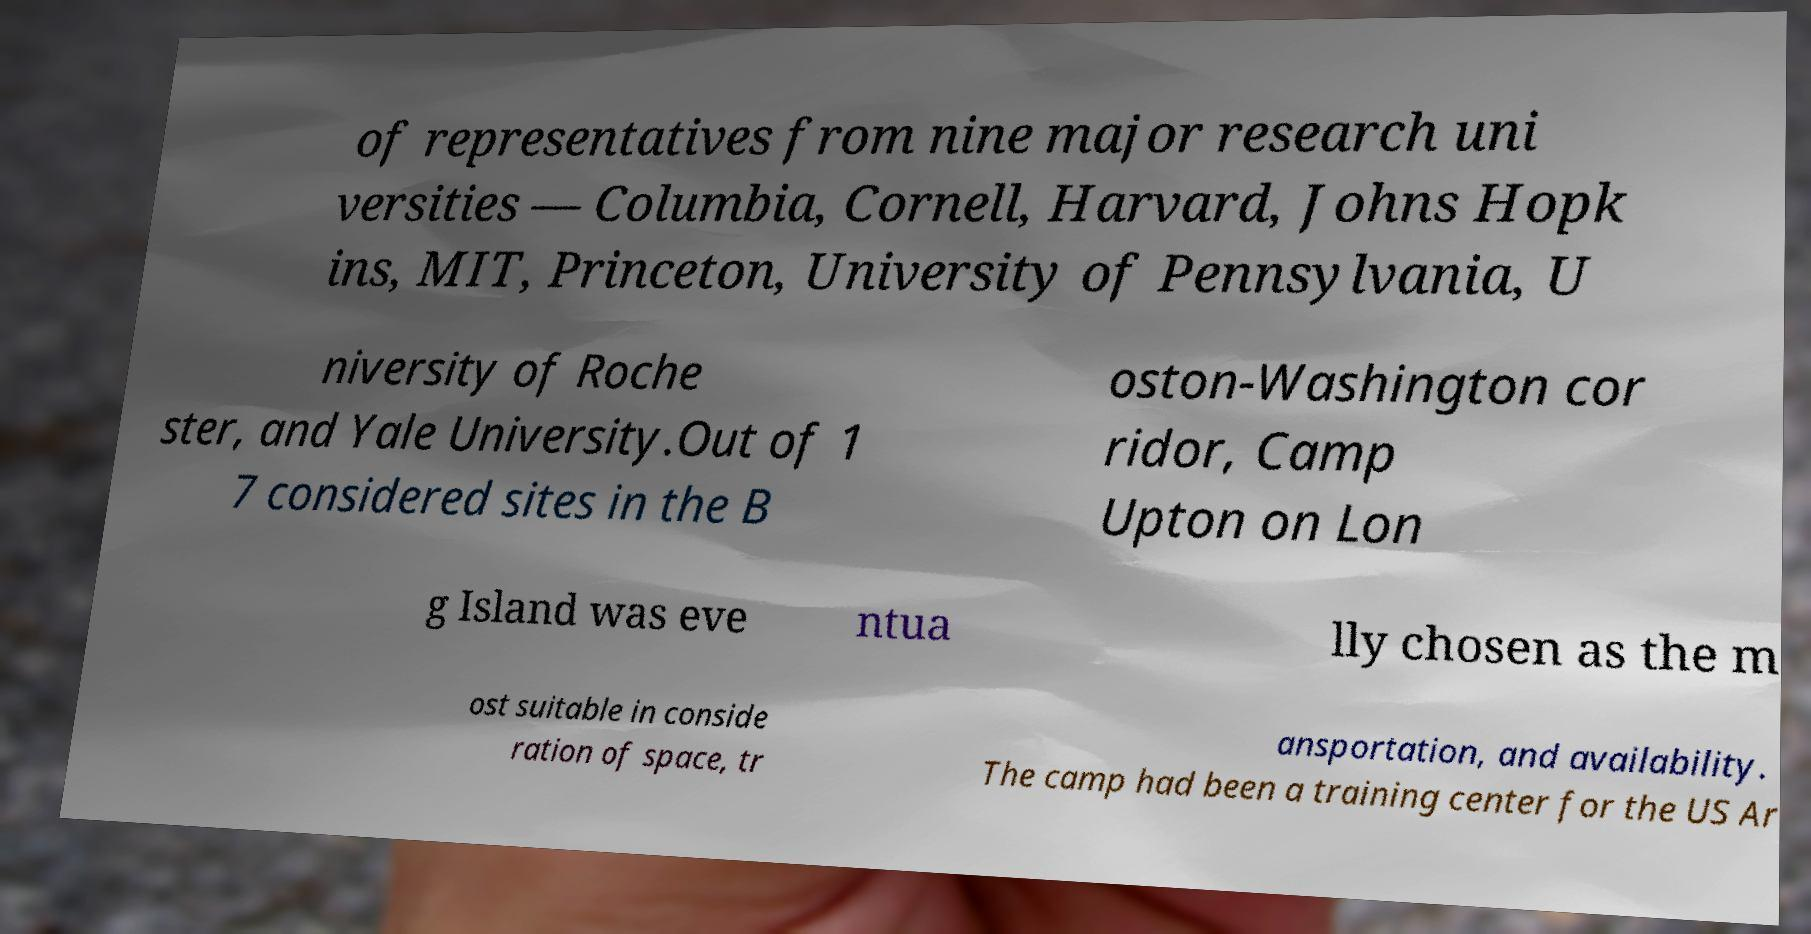Please read and relay the text visible in this image. What does it say? of representatives from nine major research uni versities — Columbia, Cornell, Harvard, Johns Hopk ins, MIT, Princeton, University of Pennsylvania, U niversity of Roche ster, and Yale University.Out of 1 7 considered sites in the B oston-Washington cor ridor, Camp Upton on Lon g Island was eve ntua lly chosen as the m ost suitable in conside ration of space, tr ansportation, and availability. The camp had been a training center for the US Ar 